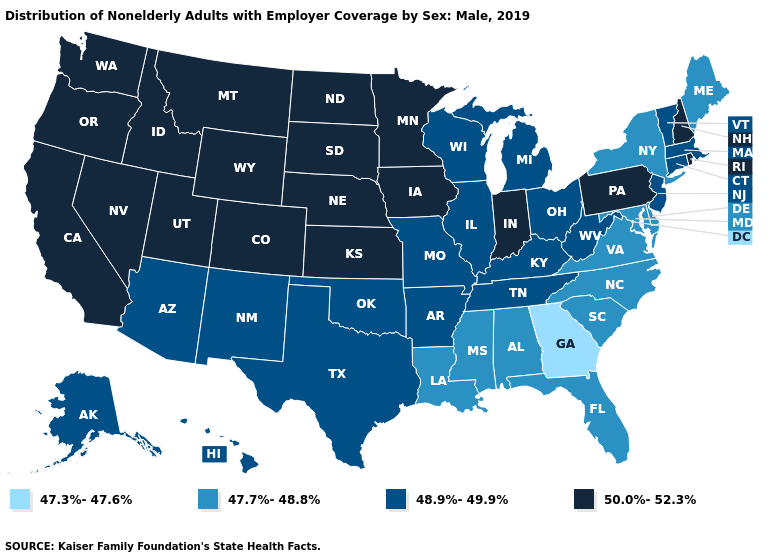What is the lowest value in the USA?
Write a very short answer. 47.3%-47.6%. Name the states that have a value in the range 48.9%-49.9%?
Quick response, please. Alaska, Arizona, Arkansas, Connecticut, Hawaii, Illinois, Kentucky, Massachusetts, Michigan, Missouri, New Jersey, New Mexico, Ohio, Oklahoma, Tennessee, Texas, Vermont, West Virginia, Wisconsin. Name the states that have a value in the range 48.9%-49.9%?
Give a very brief answer. Alaska, Arizona, Arkansas, Connecticut, Hawaii, Illinois, Kentucky, Massachusetts, Michigan, Missouri, New Jersey, New Mexico, Ohio, Oklahoma, Tennessee, Texas, Vermont, West Virginia, Wisconsin. Does Pennsylvania have a lower value than Oregon?
Write a very short answer. No. Which states hav the highest value in the Northeast?
Quick response, please. New Hampshire, Pennsylvania, Rhode Island. Name the states that have a value in the range 48.9%-49.9%?
Be succinct. Alaska, Arizona, Arkansas, Connecticut, Hawaii, Illinois, Kentucky, Massachusetts, Michigan, Missouri, New Jersey, New Mexico, Ohio, Oklahoma, Tennessee, Texas, Vermont, West Virginia, Wisconsin. Which states hav the highest value in the Northeast?
Quick response, please. New Hampshire, Pennsylvania, Rhode Island. Name the states that have a value in the range 48.9%-49.9%?
Be succinct. Alaska, Arizona, Arkansas, Connecticut, Hawaii, Illinois, Kentucky, Massachusetts, Michigan, Missouri, New Jersey, New Mexico, Ohio, Oklahoma, Tennessee, Texas, Vermont, West Virginia, Wisconsin. Which states have the lowest value in the USA?
Quick response, please. Georgia. Among the states that border Iowa , which have the highest value?
Keep it brief. Minnesota, Nebraska, South Dakota. Does Minnesota have the highest value in the USA?
Give a very brief answer. Yes. Does New Jersey have the same value as Idaho?
Keep it brief. No. Does the first symbol in the legend represent the smallest category?
Write a very short answer. Yes. Name the states that have a value in the range 48.9%-49.9%?
Write a very short answer. Alaska, Arizona, Arkansas, Connecticut, Hawaii, Illinois, Kentucky, Massachusetts, Michigan, Missouri, New Jersey, New Mexico, Ohio, Oklahoma, Tennessee, Texas, Vermont, West Virginia, Wisconsin. 